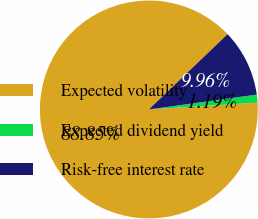Convert chart. <chart><loc_0><loc_0><loc_500><loc_500><pie_chart><fcel>Expected volatility<fcel>Expected dividend yield<fcel>Risk-free interest rate<nl><fcel>88.85%<fcel>1.19%<fcel>9.96%<nl></chart> 